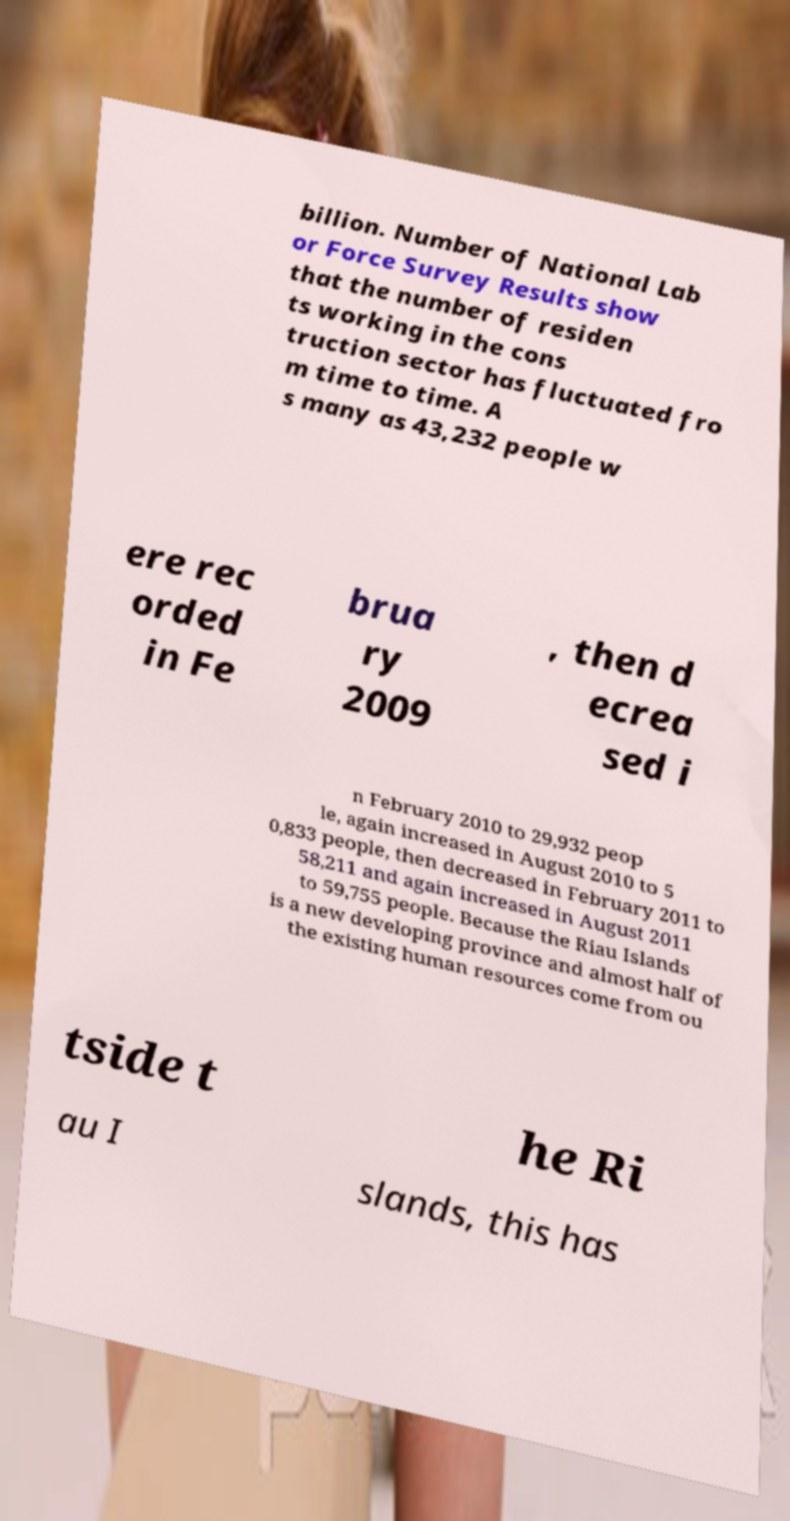Could you assist in decoding the text presented in this image and type it out clearly? billion. Number of National Lab or Force Survey Results show that the number of residen ts working in the cons truction sector has fluctuated fro m time to time. A s many as 43,232 people w ere rec orded in Fe brua ry 2009 , then d ecrea sed i n February 2010 to 29,932 peop le, again increased in August 2010 to 5 0,833 people, then decreased in February 2011 to 58,211 and again increased in August 2011 to 59,755 people. Because the Riau Islands is a new developing province and almost half of the existing human resources come from ou tside t he Ri au I slands, this has 